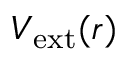<formula> <loc_0><loc_0><loc_500><loc_500>V _ { e x t } ( r )</formula> 